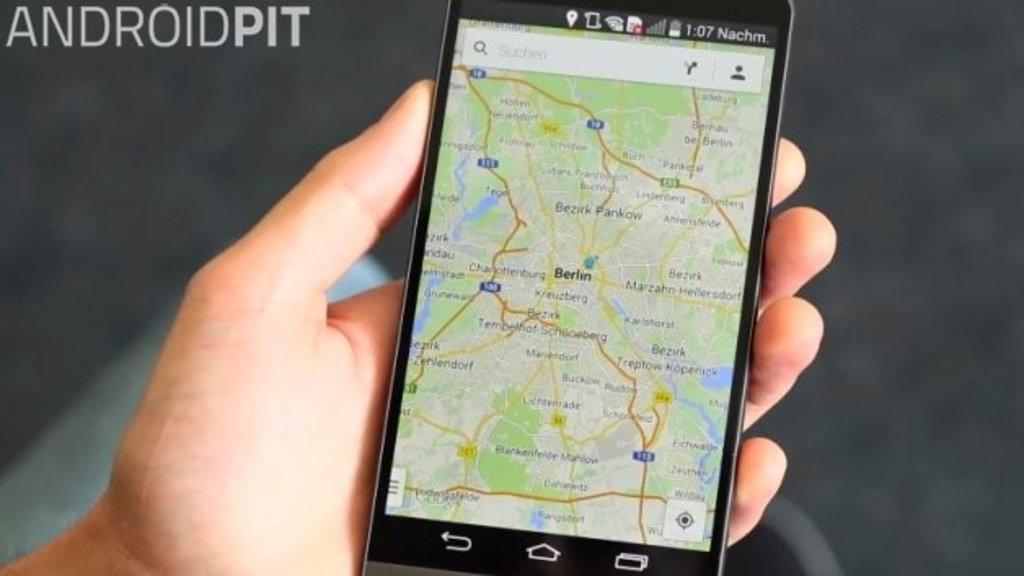Provide a one-sentence caption for the provided image. a phone with Berlin located on a map. 